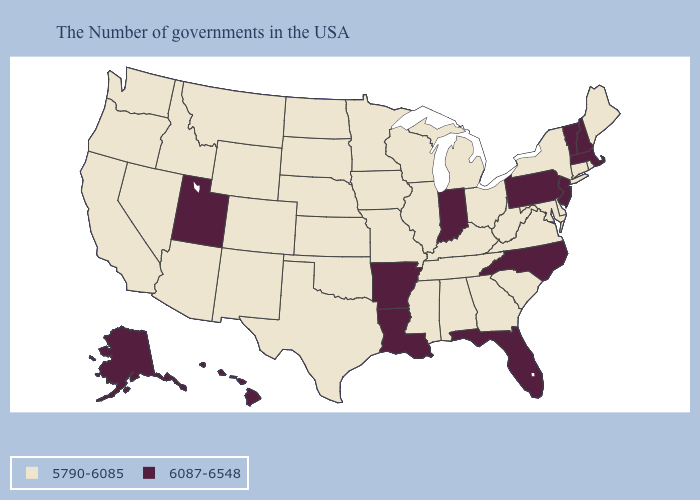Does Virginia have a higher value than Wyoming?
Give a very brief answer. No. Among the states that border Arkansas , does Oklahoma have the lowest value?
Keep it brief. Yes. What is the value of Delaware?
Keep it brief. 5790-6085. Does Missouri have the highest value in the USA?
Be succinct. No. What is the value of Colorado?
Write a very short answer. 5790-6085. Name the states that have a value in the range 6087-6548?
Write a very short answer. Massachusetts, New Hampshire, Vermont, New Jersey, Pennsylvania, North Carolina, Florida, Indiana, Louisiana, Arkansas, Utah, Alaska, Hawaii. Which states hav the highest value in the West?
Short answer required. Utah, Alaska, Hawaii. Does Pennsylvania have a lower value than Kentucky?
Write a very short answer. No. Name the states that have a value in the range 6087-6548?
Answer briefly. Massachusetts, New Hampshire, Vermont, New Jersey, Pennsylvania, North Carolina, Florida, Indiana, Louisiana, Arkansas, Utah, Alaska, Hawaii. Does Alaska have the lowest value in the West?
Concise answer only. No. Does Vermont have the lowest value in the USA?
Give a very brief answer. No. What is the highest value in the MidWest ?
Be succinct. 6087-6548. Among the states that border Kansas , which have the lowest value?
Answer briefly. Missouri, Nebraska, Oklahoma, Colorado. Which states have the highest value in the USA?
Give a very brief answer. Massachusetts, New Hampshire, Vermont, New Jersey, Pennsylvania, North Carolina, Florida, Indiana, Louisiana, Arkansas, Utah, Alaska, Hawaii. 